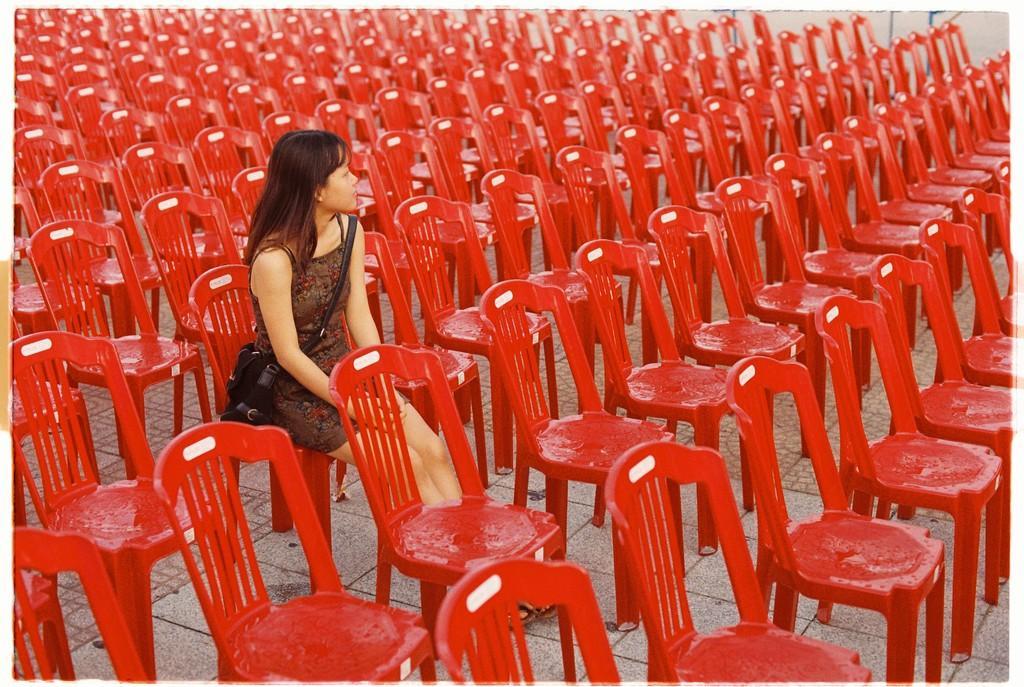Could you give a brief overview of what you see in this image? There is a woman holding a bag across a shoulders, sitting in the chairs. There are many red chairs arranged in an orderly manner in this picture. 